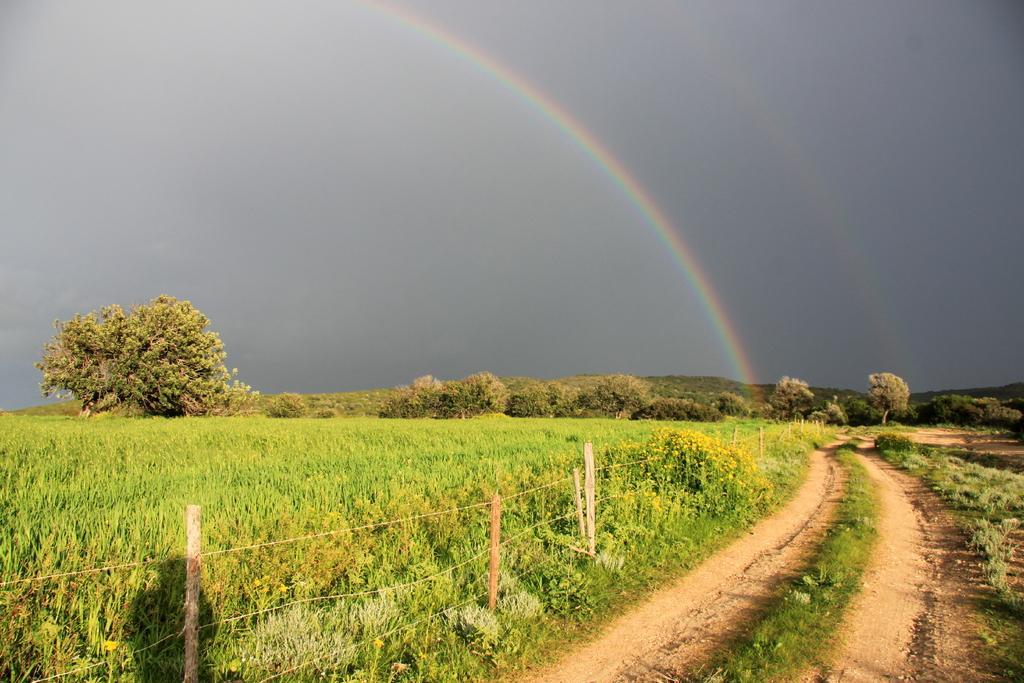How would you summarize this image in a sentence or two? This image is taken outdoors. At the top of the image there is a sky. At the bottom of the image there is a ground with grass and many plants. There is a fence. In this image there are many trees and plants. 